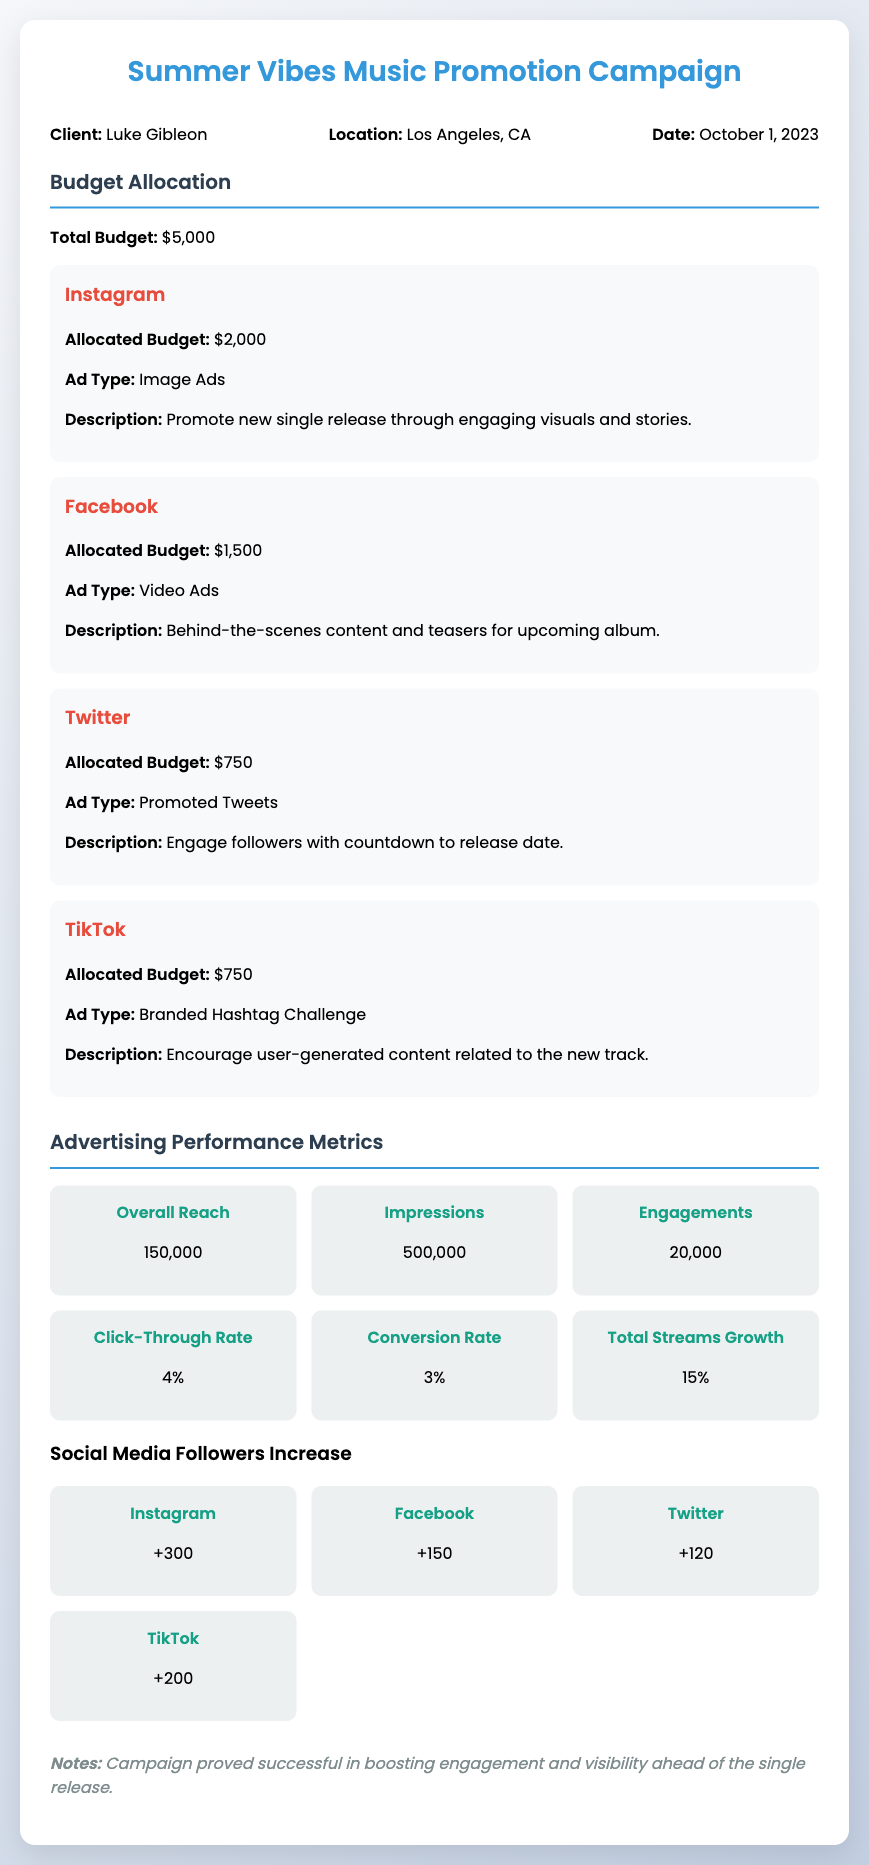What is the total budget? The total budget is stated clearly in the document under budget allocation.
Answer: $5,000 How much is allocated for Instagram? Instagram's budget allocation is detailed in the section for budget allocation.
Answer: $2,000 What is the ad type used on Facebook? The ad type for Facebook is explicitly mentioned in the Facebook platform section.
Answer: Video Ads What was the overall reach of the campaign? Overall reach is a key performance metric provided in the advertising performance metrics section.
Answer: 150,000 Which platform had the highest increase in followers? The increase in followers for each platform is listed, allowing for comparison.
Answer: Instagram What is the click-through rate? The click-through rate is part of the advertising performance metrics provided in the document.
Answer: 4% How much was allocated for TikTok? The document specifies the budget allocated for TikTok in the budget allocation section.
Answer: $750 What is mentioned in the notes section? The notes section summarizes the overall performance of the campaign in a concise statement.
Answer: Campaign proved successful in boosting engagement and visibility ahead of the single release What is the conversion rate? The conversion rate is included in the performance metrics and reflects the campaign’s effectiveness.
Answer: 3% How many followers did Twitter gain? The follower increase for Twitter is specifically provided in the social media followers increase metrics.
Answer: +120 